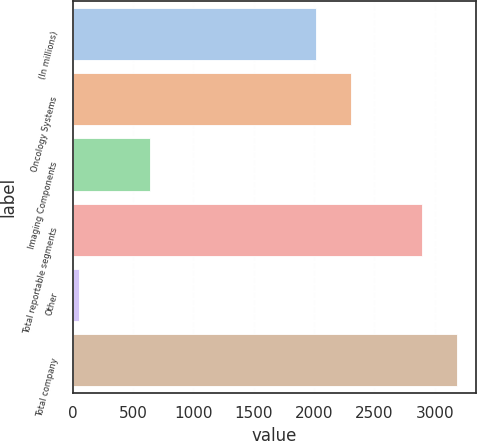<chart> <loc_0><loc_0><loc_500><loc_500><bar_chart><fcel>(In millions)<fcel>Oncology Systems<fcel>Imaging Components<fcel>Total reportable segments<fcel>Other<fcel>Total company<nl><fcel>2013<fcel>2302.46<fcel>641.9<fcel>2894.6<fcel>48.3<fcel>3184.06<nl></chart> 